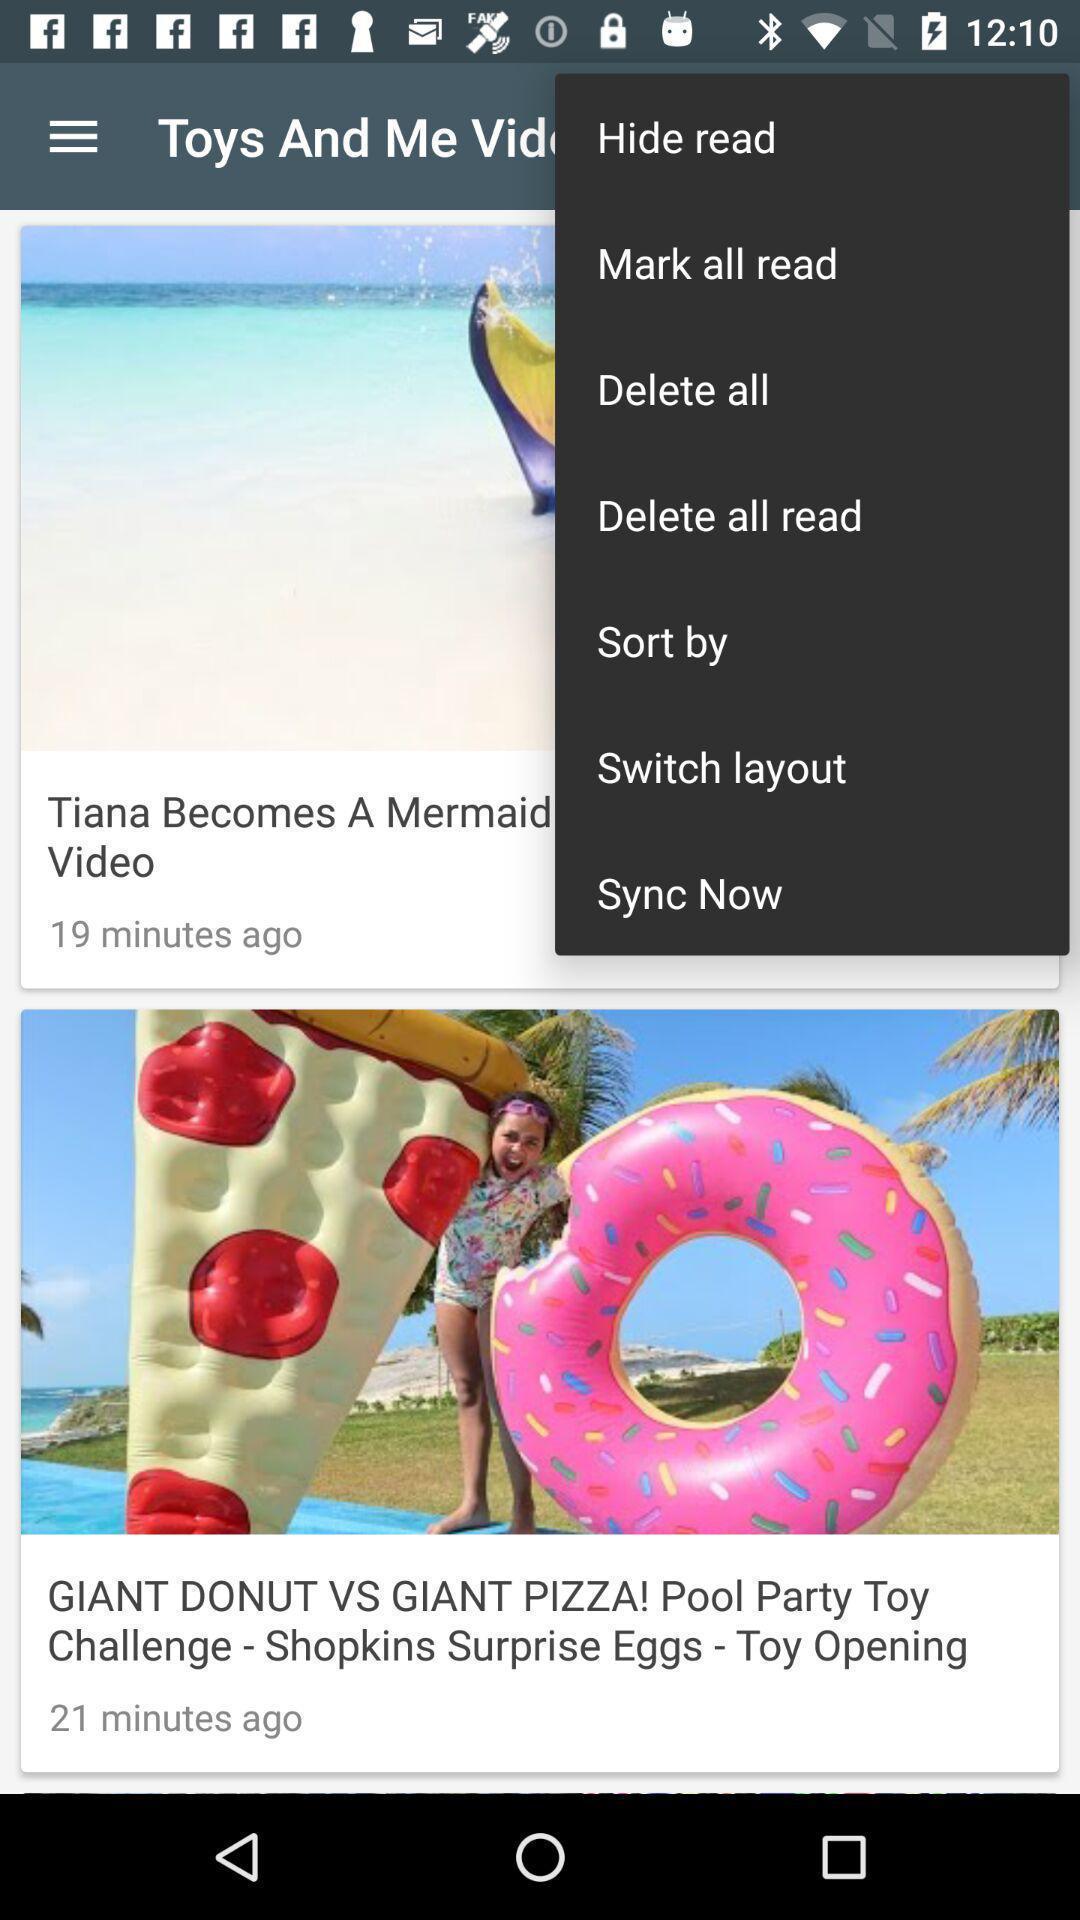Describe the visual elements of this screenshot. Screen displaying the options in more menu. 